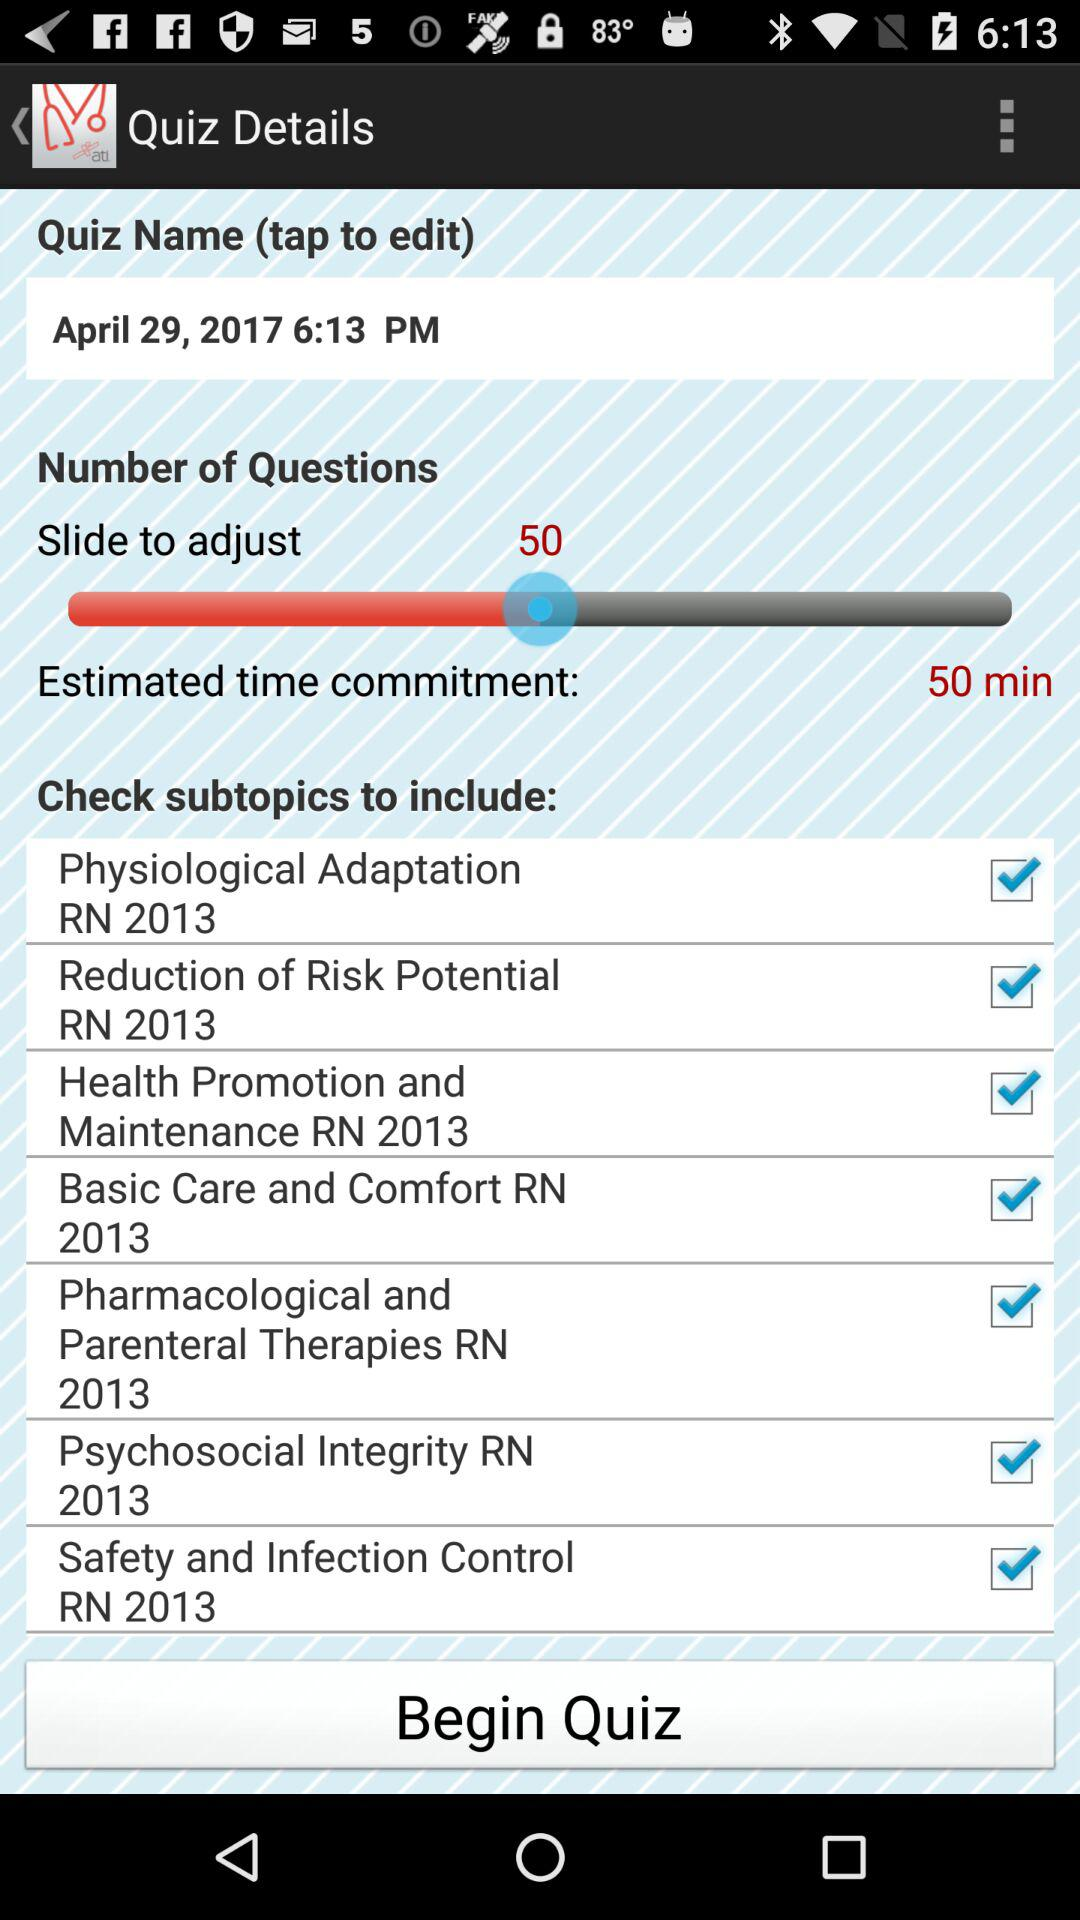What is the status of "Physiological Adaptation RN 2013"? The status of "Physiological Adaptation RN 2013" is "on". 